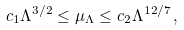<formula> <loc_0><loc_0><loc_500><loc_500>c _ { 1 } \Lambda ^ { 3 / 2 } \leq \mu _ { \Lambda } \leq c _ { 2 } \Lambda ^ { 1 2 / 7 } \, ,</formula> 